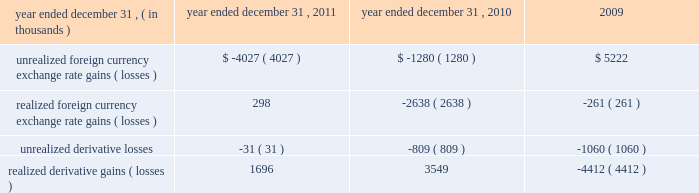From time to time , we may elect to use foreign currency forward contracts to reduce the risk from exchange rate fluctuations on intercompany transactions and projected inventory purchases for our european and canadian subsidiaries .
In addition , we may elect to enter into foreign currency forward contracts to reduce the risk associated with foreign currency exchange rate fluctuations on pound sterling denominated balance sheet items .
We do not enter into derivative financial instruments for speculative or trading purposes .
Based on the foreign currency forward contracts outstanding as of december 31 , 2011 , we receive u.s .
Dollars in exchange for canadian dollars at a weighted average contractual forward foreign currency exchange rate of 1.03 cad per $ 1.00 , u.s .
Dollars in exchange for euros at a weighted average contractual foreign currency exchange rate of 20ac0.77 per $ 1.00 and euros in exchange for pounds sterling at a weighted average contractual foreign currency exchange rate of a30.84 per 20ac1.00 .
As of december 31 , 2011 , the notional value of our outstanding foreign currency forward contracts for our canadian subsidiary was $ 51.1 million with contract maturities of 1 month or less , and the notional value of our outstanding foreign currency forward contracts for our european subsidiary was $ 50.0 million with contract maturities of 1 month .
As of december 31 , 2011 , the notional value of our outstanding foreign currency forward contract used to mitigate the foreign currency exchange rate fluctuations on pound sterling denominated balance sheet items was 20ac10.5 million , or $ 13.6 million , with a contract maturity of 1 month .
The foreign currency forward contracts are not designated as cash flow hedges , and accordingly , changes in their fair value are recorded in other expense , net on the consolidated statements of income .
The fair values of our foreign currency forward contracts were liabilities of $ 0.7 million and $ 0.6 million as of december 31 , 2011 and 2010 , respectively , and were included in accrued expenses on the consolidated balance sheet .
Refer to note 10 to the consolidated financial statements for a discussion of the fair value measurements .
Included in other expense , net were the following amounts related to changes in foreign currency exchange rates and derivative foreign currency forward contracts: .
We enter into foreign currency forward contracts with major financial institutions with investment grade credit ratings and are exposed to credit losses in the event of non-performance by these financial institutions .
This credit risk is generally limited to the unrealized gains in the foreign currency forward contracts .
However , we monitor the credit quality of these financial institutions and consider the risk of counterparty default to be minimal .
Although we have entered into foreign currency forward contracts to minimize some of the impact of foreign currency exchange rate fluctuations on future cash flows , we cannot be assured that foreign currency exchange rate fluctuations will not have a material adverse impact on our financial condition and results of operations .
Inflation inflationary factors such as increases in the cost of our product and overhead costs may adversely affect our operating results .
Although we do not believe that inflation has had a material impact on our financial position or results of operations to date , a high rate of inflation in the future may have an adverse effect on our ability to maintain current levels of gross margin and selling , general and administrative expenses as a percentage of net revenues if the selling prices of our products do not increase with these increased costs. .
As of december 312011 what was the percentage increase in the unrealized foreign currency exchange rate gains ( losses )? 
Rationale: the was a 215% increase unrealized foreign currency exchange rate gains ( losses ) in 2011
Computations: ((-4027 - -1280) / -1280)
Answer: 2.14609. 